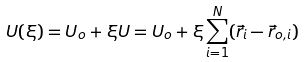<formula> <loc_0><loc_0><loc_500><loc_500>U ( \xi ) = U _ { o } + \xi U = U _ { o } + \xi \sum _ { i = 1 } ^ { N } ( \vec { r } _ { i } - \vec { r } _ { o , i } )</formula> 